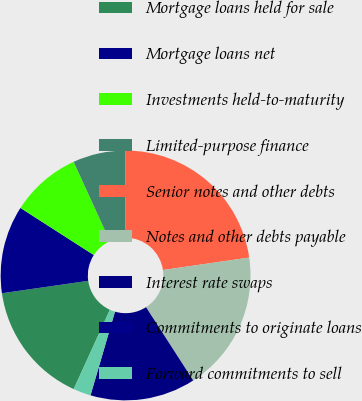<chart> <loc_0><loc_0><loc_500><loc_500><pie_chart><fcel>Mortgage loans held for sale<fcel>Mortgage loans net<fcel>Investments held-to-maturity<fcel>Limited-purpose finance<fcel>Senior notes and other debts<fcel>Notes and other debts payable<fcel>Interest rate swaps<fcel>Commitments to originate loans<fcel>Forward commitments to sell<nl><fcel>15.91%<fcel>11.36%<fcel>9.09%<fcel>6.82%<fcel>22.72%<fcel>18.18%<fcel>13.63%<fcel>0.01%<fcel>2.28%<nl></chart> 